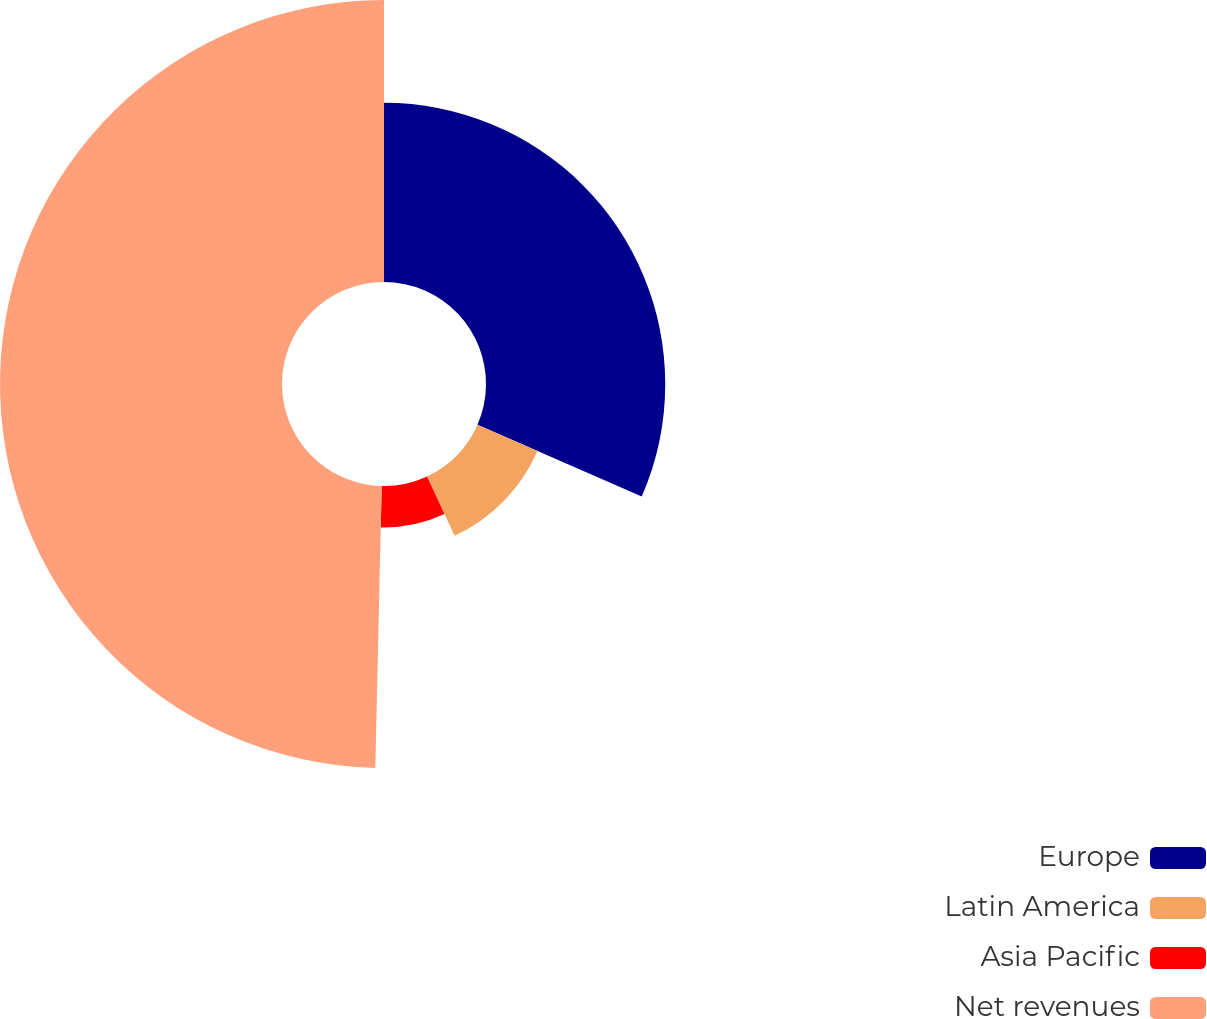<chart> <loc_0><loc_0><loc_500><loc_500><pie_chart><fcel>Europe<fcel>Latin America<fcel>Asia Pacific<fcel>Net revenues<nl><fcel>31.55%<fcel>11.52%<fcel>7.29%<fcel>49.64%<nl></chart> 